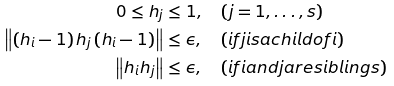<formula> <loc_0><loc_0><loc_500><loc_500>0 \leq h _ { j } & \leq 1 , \quad ( j = 1 , \dots , s ) \\ \left \| \left ( h _ { i } - 1 \right ) h _ { j } \left ( h _ { i } - 1 \right ) \right \| & \leq \epsilon , \quad ( i f j i s a c h i l d o f i ) \\ \left \| h _ { i } h _ { j } \right \| & \leq \epsilon , \quad ( i f i a n d j a r e s i b l i n g s )</formula> 